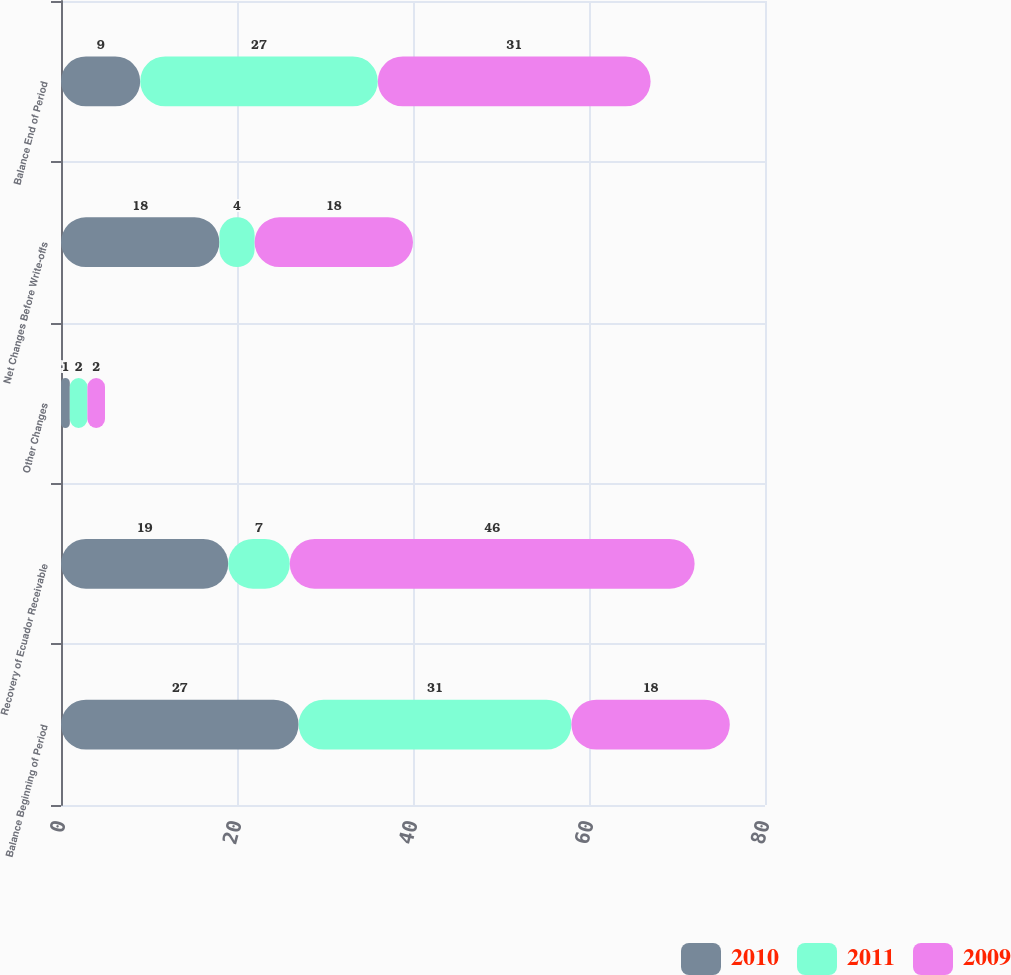Convert chart to OTSL. <chart><loc_0><loc_0><loc_500><loc_500><stacked_bar_chart><ecel><fcel>Balance Beginning of Period<fcel>Recovery of Ecuador Receivable<fcel>Other Changes<fcel>Net Changes Before Write-offs<fcel>Balance End of Period<nl><fcel>2010<fcel>27<fcel>19<fcel>1<fcel>18<fcel>9<nl><fcel>2011<fcel>31<fcel>7<fcel>2<fcel>4<fcel>27<nl><fcel>2009<fcel>18<fcel>46<fcel>2<fcel>18<fcel>31<nl></chart> 